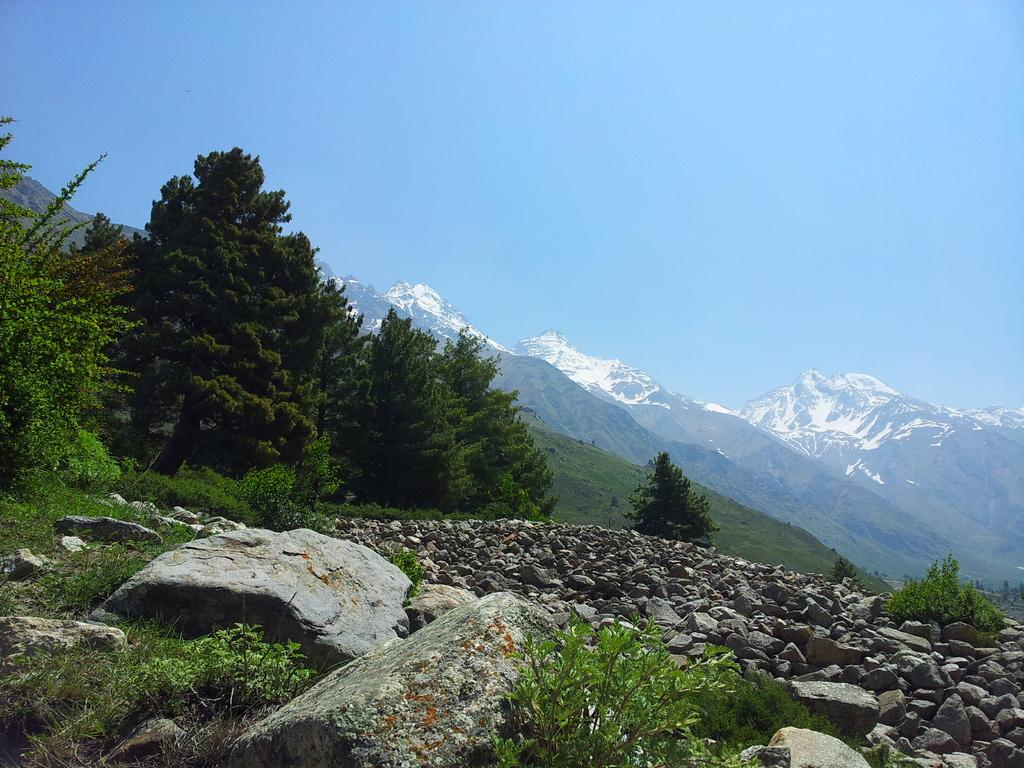What type of natural elements can be seen in the image? There are stones, grass, plants, mountains, and trees in the image. What is the color of the sky in the image? The sky is visible in the image. Can you describe the vegetation present in the image? There are plants and trees in the image. What type of lipstick is the father wearing in the image? There is no father or lipstick present in the image. Can you describe the arch that the plants are forming in the image? There is no arch formed by the plants in the image. 